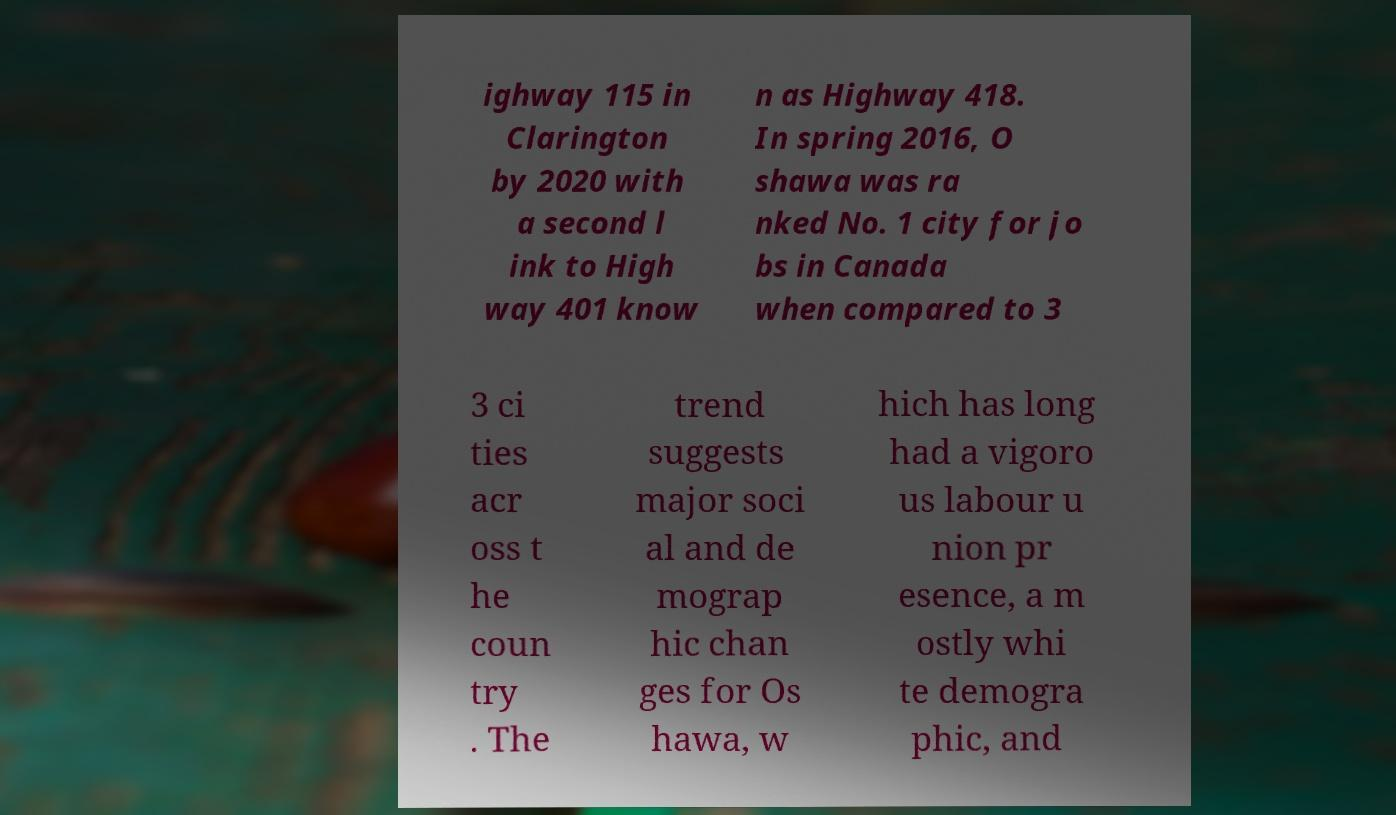Could you assist in decoding the text presented in this image and type it out clearly? ighway 115 in Clarington by 2020 with a second l ink to High way 401 know n as Highway 418. In spring 2016, O shawa was ra nked No. 1 city for jo bs in Canada when compared to 3 3 ci ties acr oss t he coun try . The trend suggests major soci al and de mograp hic chan ges for Os hawa, w hich has long had a vigoro us labour u nion pr esence, a m ostly whi te demogra phic, and 